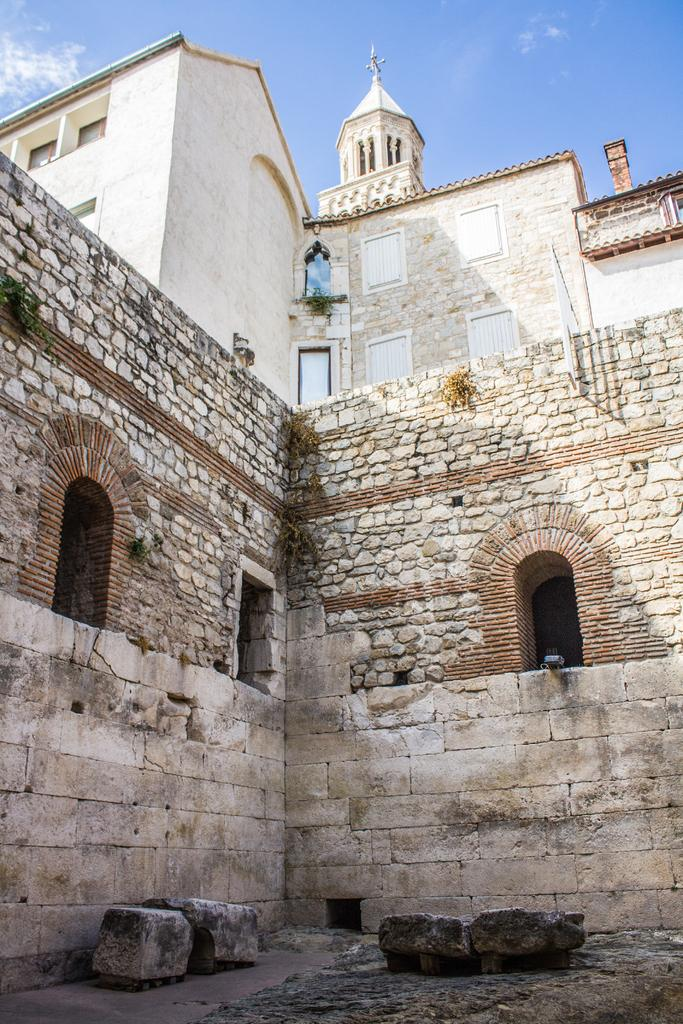What type of structures can be seen in the image? There are buildings in the image. What natural elements are present in the image? There are rocks in the image. What man-made elements are present in the image besides buildings? There are walls in the image. What else can be seen in the image besides buildings, rocks, and walls? There are other objects in the image. What is visible in the background of the image? The sky is visible in the background of the image. Where is the shop located in the image? There is no shop present in the image. What type of question is being asked in the image? There is no question present in the image. 